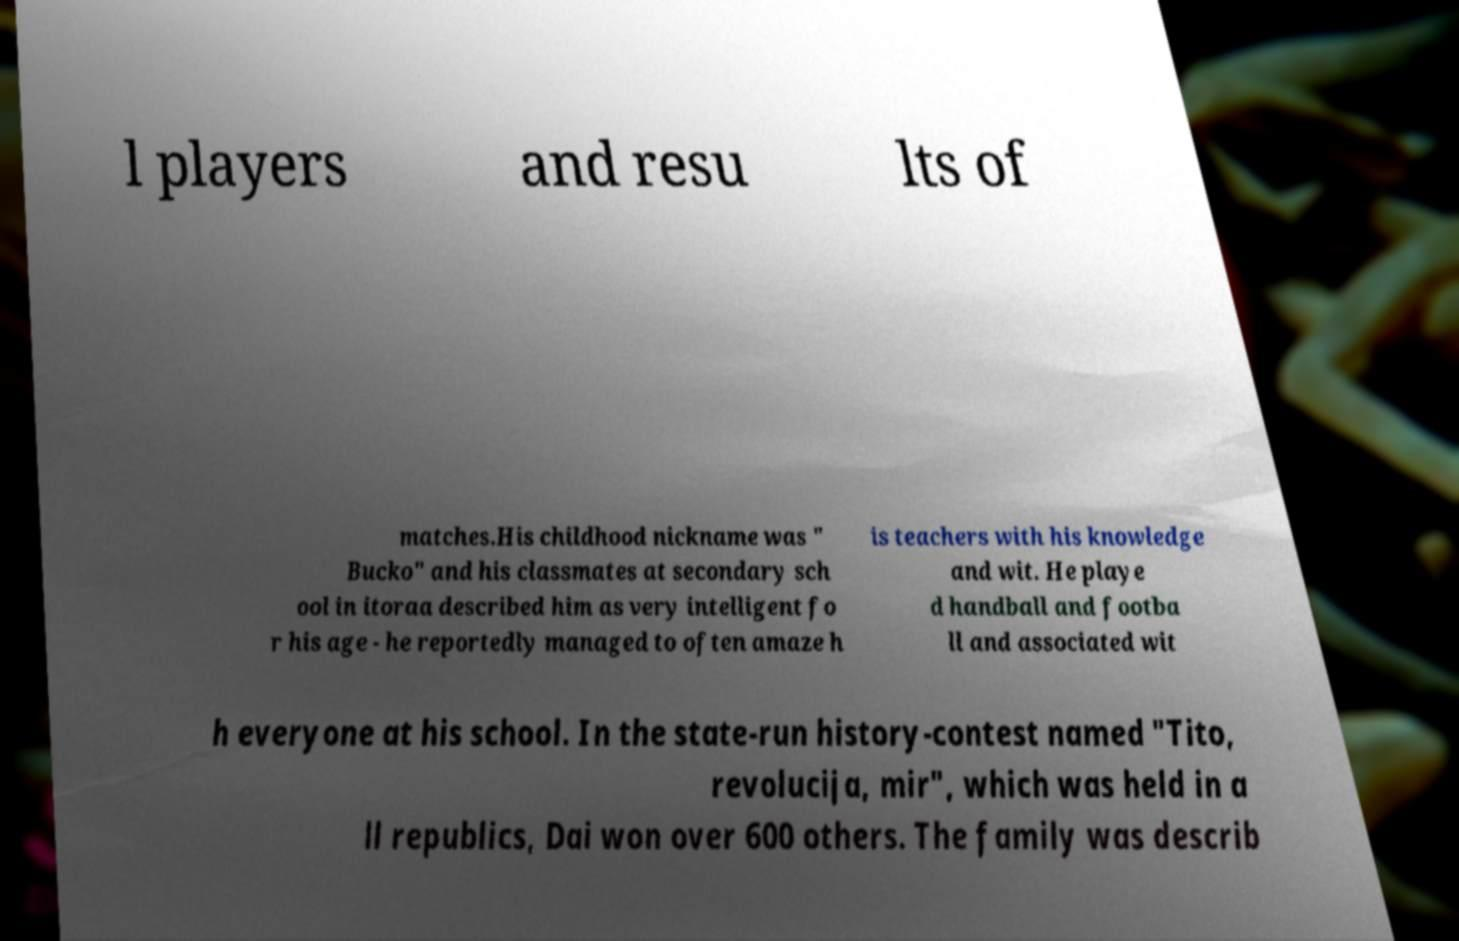Can you read and provide the text displayed in the image?This photo seems to have some interesting text. Can you extract and type it out for me? l players and resu lts of matches.His childhood nickname was " Bucko" and his classmates at secondary sch ool in itoraa described him as very intelligent fo r his age - he reportedly managed to often amaze h is teachers with his knowledge and wit. He playe d handball and footba ll and associated wit h everyone at his school. In the state-run history-contest named "Tito, revolucija, mir", which was held in a ll republics, Dai won over 600 others. The family was describ 